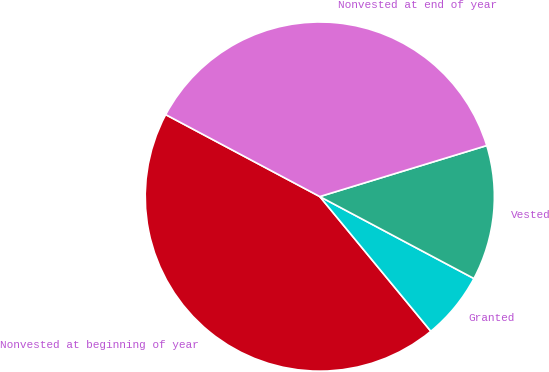Convert chart to OTSL. <chart><loc_0><loc_0><loc_500><loc_500><pie_chart><fcel>Nonvested at beginning of year<fcel>Granted<fcel>Vested<fcel>Nonvested at end of year<nl><fcel>43.75%<fcel>6.25%<fcel>12.5%<fcel>37.5%<nl></chart> 